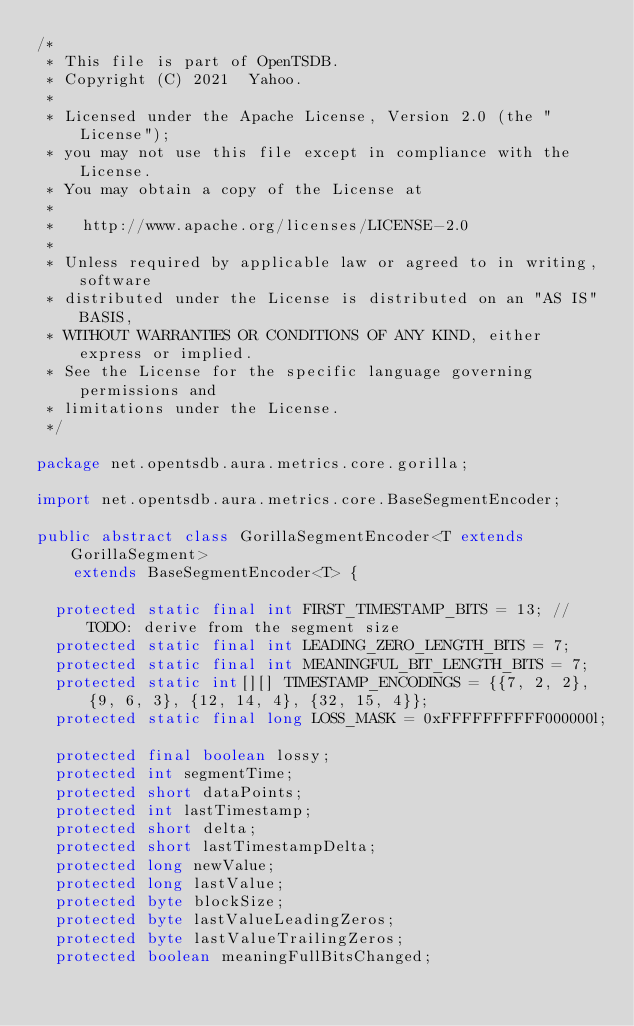<code> <loc_0><loc_0><loc_500><loc_500><_Java_>/*
 * This file is part of OpenTSDB.
 * Copyright (C) 2021  Yahoo.
 *
 * Licensed under the Apache License, Version 2.0 (the "License");
 * you may not use this file except in compliance with the License.
 * You may obtain a copy of the License at
 *
 *   http://www.apache.org/licenses/LICENSE-2.0
 *
 * Unless required by applicable law or agreed to in writing, software
 * distributed under the License is distributed on an "AS IS" BASIS,
 * WITHOUT WARRANTIES OR CONDITIONS OF ANY KIND, either express or implied.
 * See the License for the specific language governing permissions and
 * limitations under the License.
 */

package net.opentsdb.aura.metrics.core.gorilla;

import net.opentsdb.aura.metrics.core.BaseSegmentEncoder;

public abstract class GorillaSegmentEncoder<T extends GorillaSegment>
    extends BaseSegmentEncoder<T> {

  protected static final int FIRST_TIMESTAMP_BITS = 13; // TODO: derive from the segment size
  protected static final int LEADING_ZERO_LENGTH_BITS = 7;
  protected static final int MEANINGFUL_BIT_LENGTH_BITS = 7;
  protected static int[][] TIMESTAMP_ENCODINGS = {{7, 2, 2}, {9, 6, 3}, {12, 14, 4}, {32, 15, 4}};
  protected static final long LOSS_MASK = 0xFFFFFFFFFF000000l;

  protected final boolean lossy;
  protected int segmentTime;
  protected short dataPoints;
  protected int lastTimestamp;
  protected short delta;
  protected short lastTimestampDelta;
  protected long newValue;
  protected long lastValue;
  protected byte blockSize;
  protected byte lastValueLeadingZeros;
  protected byte lastValueTrailingZeros;
  protected boolean meaningFullBitsChanged;
</code> 